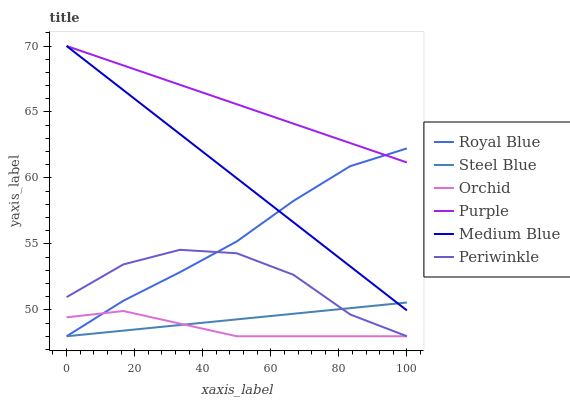Does Orchid have the minimum area under the curve?
Answer yes or no. Yes. Does Purple have the maximum area under the curve?
Answer yes or no. Yes. Does Medium Blue have the minimum area under the curve?
Answer yes or no. No. Does Medium Blue have the maximum area under the curve?
Answer yes or no. No. Is Steel Blue the smoothest?
Answer yes or no. Yes. Is Periwinkle the roughest?
Answer yes or no. Yes. Is Medium Blue the smoothest?
Answer yes or no. No. Is Medium Blue the roughest?
Answer yes or no. No. Does Medium Blue have the lowest value?
Answer yes or no. No. Does Medium Blue have the highest value?
Answer yes or no. Yes. Does Steel Blue have the highest value?
Answer yes or no. No. Is Periwinkle less than Medium Blue?
Answer yes or no. Yes. Is Purple greater than Steel Blue?
Answer yes or no. Yes. Does Medium Blue intersect Steel Blue?
Answer yes or no. Yes. Is Medium Blue less than Steel Blue?
Answer yes or no. No. Is Medium Blue greater than Steel Blue?
Answer yes or no. No. Does Periwinkle intersect Medium Blue?
Answer yes or no. No. 